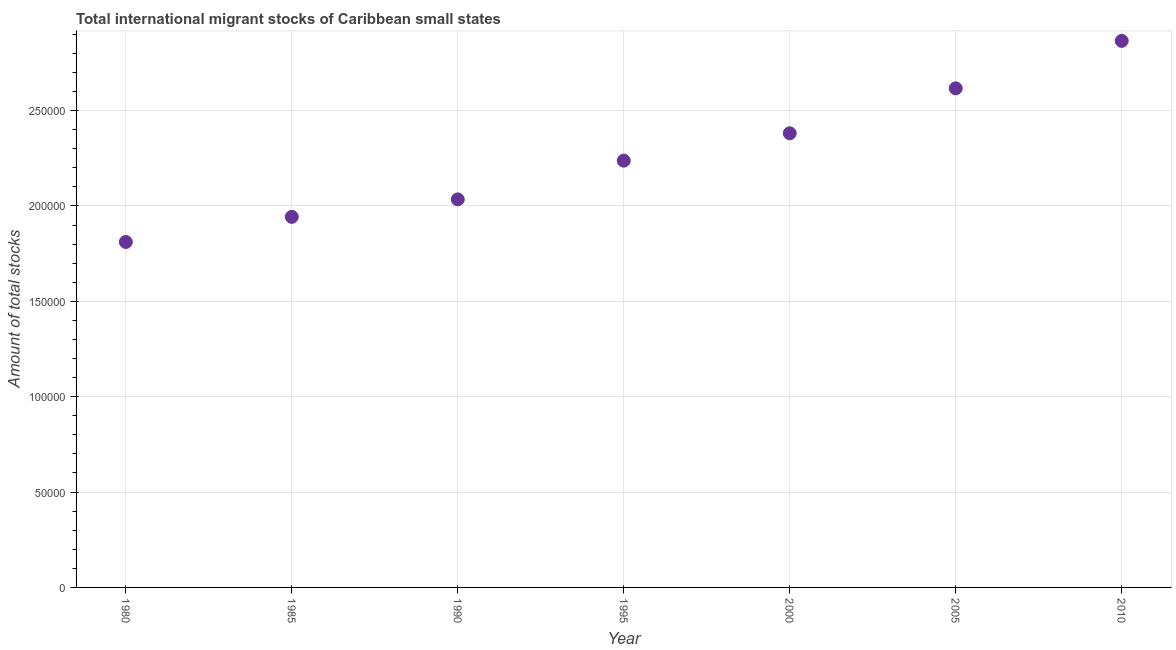What is the total number of international migrant stock in 2010?
Offer a very short reply. 2.87e+05. Across all years, what is the maximum total number of international migrant stock?
Offer a terse response. 2.87e+05. Across all years, what is the minimum total number of international migrant stock?
Provide a short and direct response. 1.81e+05. In which year was the total number of international migrant stock maximum?
Offer a very short reply. 2010. What is the sum of the total number of international migrant stock?
Offer a very short reply. 1.59e+06. What is the difference between the total number of international migrant stock in 1980 and 2010?
Keep it short and to the point. -1.05e+05. What is the average total number of international migrant stock per year?
Offer a terse response. 2.27e+05. What is the median total number of international migrant stock?
Your response must be concise. 2.24e+05. What is the ratio of the total number of international migrant stock in 2000 to that in 2010?
Provide a short and direct response. 0.83. Is the total number of international migrant stock in 1980 less than that in 1990?
Ensure brevity in your answer.  Yes. Is the difference between the total number of international migrant stock in 1985 and 1990 greater than the difference between any two years?
Your answer should be very brief. No. What is the difference between the highest and the second highest total number of international migrant stock?
Your response must be concise. 2.49e+04. What is the difference between the highest and the lowest total number of international migrant stock?
Ensure brevity in your answer.  1.05e+05. In how many years, is the total number of international migrant stock greater than the average total number of international migrant stock taken over all years?
Your answer should be compact. 3. Does the total number of international migrant stock monotonically increase over the years?
Offer a very short reply. Yes. Does the graph contain any zero values?
Your answer should be very brief. No. Does the graph contain grids?
Provide a short and direct response. Yes. What is the title of the graph?
Your response must be concise. Total international migrant stocks of Caribbean small states. What is the label or title of the X-axis?
Your response must be concise. Year. What is the label or title of the Y-axis?
Your answer should be very brief. Amount of total stocks. What is the Amount of total stocks in 1980?
Give a very brief answer. 1.81e+05. What is the Amount of total stocks in 1985?
Offer a terse response. 1.94e+05. What is the Amount of total stocks in 1990?
Your answer should be very brief. 2.03e+05. What is the Amount of total stocks in 1995?
Offer a very short reply. 2.24e+05. What is the Amount of total stocks in 2000?
Your answer should be compact. 2.38e+05. What is the Amount of total stocks in 2005?
Your answer should be compact. 2.62e+05. What is the Amount of total stocks in 2010?
Keep it short and to the point. 2.87e+05. What is the difference between the Amount of total stocks in 1980 and 1985?
Your answer should be compact. -1.32e+04. What is the difference between the Amount of total stocks in 1980 and 1990?
Keep it short and to the point. -2.23e+04. What is the difference between the Amount of total stocks in 1980 and 1995?
Keep it short and to the point. -4.26e+04. What is the difference between the Amount of total stocks in 1980 and 2000?
Provide a short and direct response. -5.70e+04. What is the difference between the Amount of total stocks in 1980 and 2005?
Make the answer very short. -8.06e+04. What is the difference between the Amount of total stocks in 1980 and 2010?
Offer a very short reply. -1.05e+05. What is the difference between the Amount of total stocks in 1985 and 1990?
Offer a terse response. -9157. What is the difference between the Amount of total stocks in 1985 and 1995?
Your answer should be compact. -2.95e+04. What is the difference between the Amount of total stocks in 1985 and 2000?
Give a very brief answer. -4.38e+04. What is the difference between the Amount of total stocks in 1985 and 2005?
Your answer should be compact. -6.74e+04. What is the difference between the Amount of total stocks in 1985 and 2010?
Give a very brief answer. -9.23e+04. What is the difference between the Amount of total stocks in 1990 and 1995?
Ensure brevity in your answer.  -2.03e+04. What is the difference between the Amount of total stocks in 1990 and 2000?
Offer a terse response. -3.47e+04. What is the difference between the Amount of total stocks in 1990 and 2005?
Provide a succinct answer. -5.82e+04. What is the difference between the Amount of total stocks in 1990 and 2010?
Ensure brevity in your answer.  -8.31e+04. What is the difference between the Amount of total stocks in 1995 and 2000?
Provide a succinct answer. -1.43e+04. What is the difference between the Amount of total stocks in 1995 and 2005?
Your answer should be compact. -3.79e+04. What is the difference between the Amount of total stocks in 1995 and 2010?
Give a very brief answer. -6.28e+04. What is the difference between the Amount of total stocks in 2000 and 2005?
Your answer should be very brief. -2.36e+04. What is the difference between the Amount of total stocks in 2000 and 2010?
Your answer should be compact. -4.84e+04. What is the difference between the Amount of total stocks in 2005 and 2010?
Keep it short and to the point. -2.49e+04. What is the ratio of the Amount of total stocks in 1980 to that in 1985?
Give a very brief answer. 0.93. What is the ratio of the Amount of total stocks in 1980 to that in 1990?
Your answer should be compact. 0.89. What is the ratio of the Amount of total stocks in 1980 to that in 1995?
Your response must be concise. 0.81. What is the ratio of the Amount of total stocks in 1980 to that in 2000?
Offer a terse response. 0.76. What is the ratio of the Amount of total stocks in 1980 to that in 2005?
Offer a very short reply. 0.69. What is the ratio of the Amount of total stocks in 1980 to that in 2010?
Your answer should be compact. 0.63. What is the ratio of the Amount of total stocks in 1985 to that in 1990?
Your answer should be very brief. 0.95. What is the ratio of the Amount of total stocks in 1985 to that in 1995?
Make the answer very short. 0.87. What is the ratio of the Amount of total stocks in 1985 to that in 2000?
Offer a very short reply. 0.82. What is the ratio of the Amount of total stocks in 1985 to that in 2005?
Provide a short and direct response. 0.74. What is the ratio of the Amount of total stocks in 1985 to that in 2010?
Give a very brief answer. 0.68. What is the ratio of the Amount of total stocks in 1990 to that in 1995?
Make the answer very short. 0.91. What is the ratio of the Amount of total stocks in 1990 to that in 2000?
Ensure brevity in your answer.  0.85. What is the ratio of the Amount of total stocks in 1990 to that in 2005?
Offer a terse response. 0.78. What is the ratio of the Amount of total stocks in 1990 to that in 2010?
Offer a terse response. 0.71. What is the ratio of the Amount of total stocks in 1995 to that in 2000?
Provide a short and direct response. 0.94. What is the ratio of the Amount of total stocks in 1995 to that in 2005?
Your response must be concise. 0.85. What is the ratio of the Amount of total stocks in 1995 to that in 2010?
Keep it short and to the point. 0.78. What is the ratio of the Amount of total stocks in 2000 to that in 2005?
Your answer should be compact. 0.91. What is the ratio of the Amount of total stocks in 2000 to that in 2010?
Your response must be concise. 0.83. What is the ratio of the Amount of total stocks in 2005 to that in 2010?
Your answer should be compact. 0.91. 